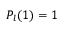Convert formula to latex. <formula><loc_0><loc_0><loc_500><loc_500>P _ { l } ( 1 ) = 1</formula> 